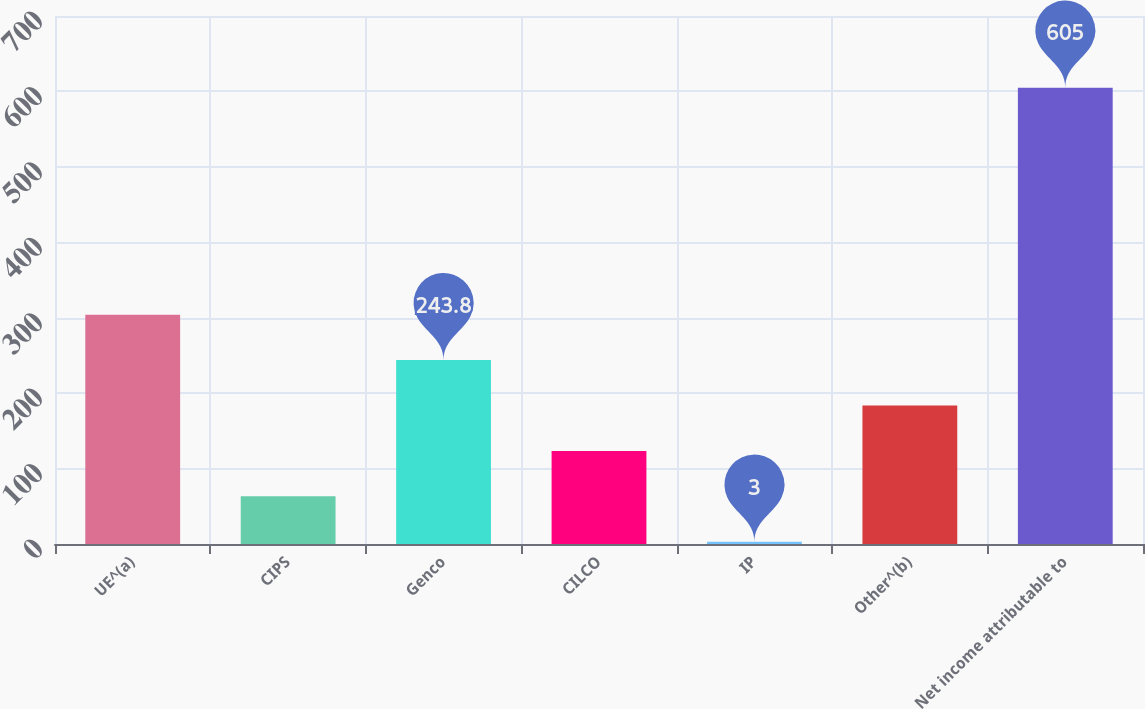<chart> <loc_0><loc_0><loc_500><loc_500><bar_chart><fcel>UE^(a)<fcel>CIPS<fcel>Genco<fcel>CILCO<fcel>IP<fcel>Other^(b)<fcel>Net income attributable to<nl><fcel>304<fcel>63.2<fcel>243.8<fcel>123.4<fcel>3<fcel>183.6<fcel>605<nl></chart> 